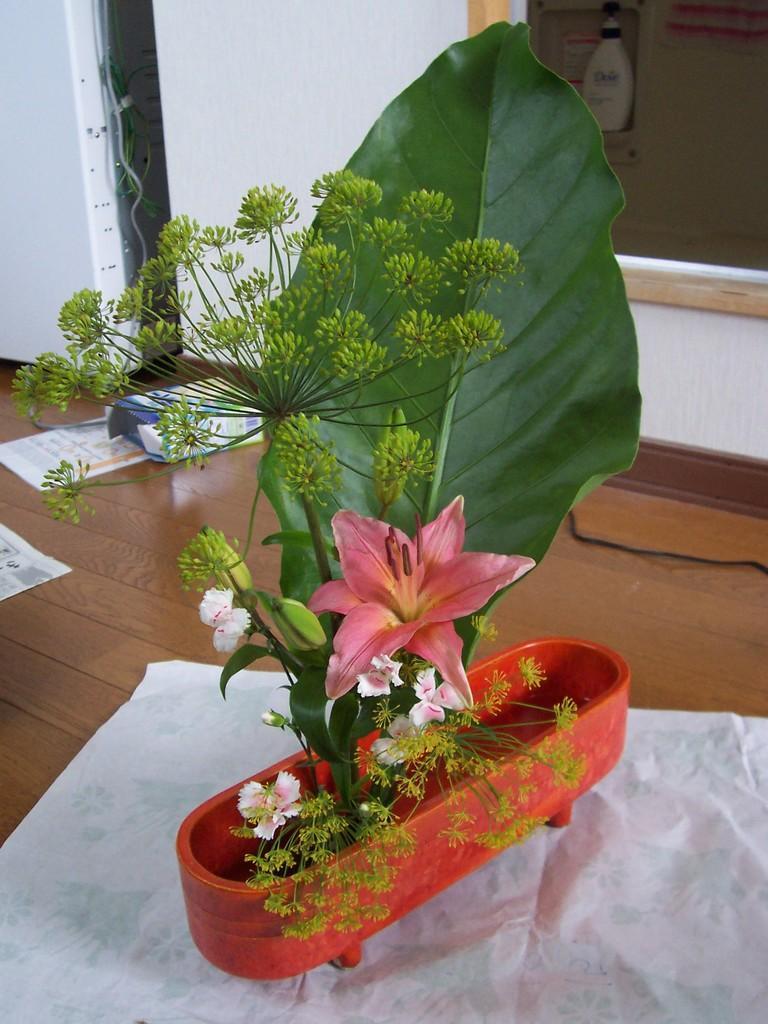Can you describe this image briefly? In the foreground of this image, there is a plant potted in a tub. In the background, on surface there is a cable, card board box, and paper placed on it. On the top, there is a wall and a window. 